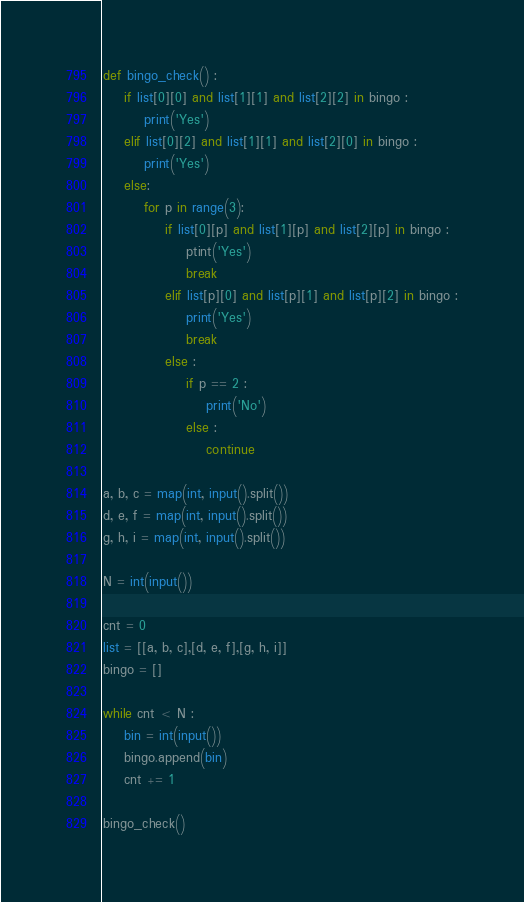Convert code to text. <code><loc_0><loc_0><loc_500><loc_500><_Python_>def bingo_check() :
    if list[0][0] and list[1][1] and list[2][2] in bingo :
        print('Yes')
    elif list[0][2] and list[1][1] and list[2][0] in bingo :
        print('Yes')
    else:
        for p in range(3):
            if list[0][p] and list[1][p] and list[2][p] in bingo :
                ptint('Yes')
                break
            elif list[p][0] and list[p][1] and list[p][2] in bingo :
                print('Yes')
                break
            else :
                if p == 2 :
                    print('No')
                else :
                    continue

a, b, c = map(int, input().split())
d, e, f = map(int, input().split())
g, h, i = map(int, input().split())

N = int(input())

cnt = 0
list = [[a, b, c],[d, e, f],[g, h, i]]
bingo = []

while cnt < N :
    bin = int(input())
    bingo.append(bin)
    cnt += 1

bingo_check()
</code> 